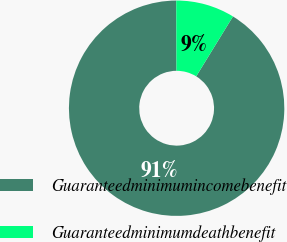Convert chart to OTSL. <chart><loc_0><loc_0><loc_500><loc_500><pie_chart><fcel>Guaranteedminimumincomebenefit<fcel>Guaranteedminimumdeathbenefit<nl><fcel>91.18%<fcel>8.82%<nl></chart> 